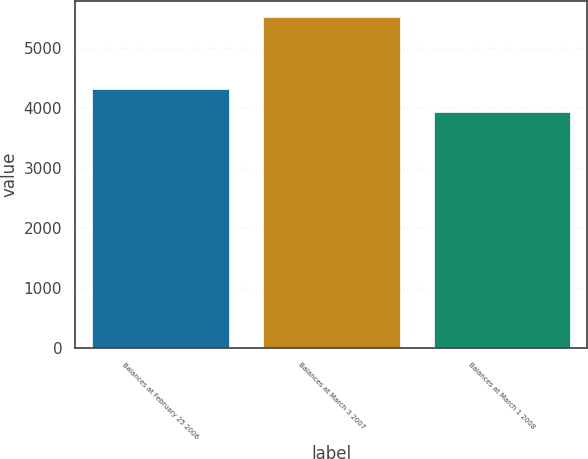Convert chart. <chart><loc_0><loc_0><loc_500><loc_500><bar_chart><fcel>Balances at February 25 2006<fcel>Balances at March 3 2007<fcel>Balances at March 1 2008<nl><fcel>4304<fcel>5507<fcel>3933<nl></chart> 